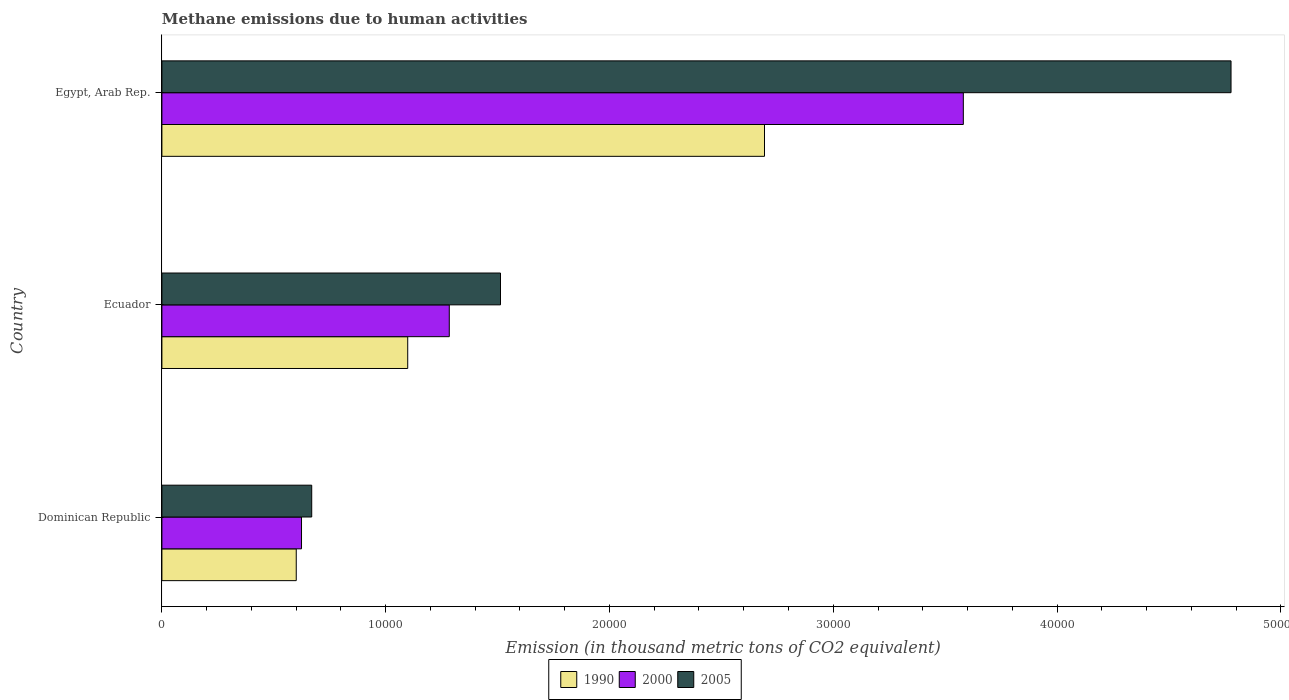How many different coloured bars are there?
Make the answer very short. 3. Are the number of bars per tick equal to the number of legend labels?
Ensure brevity in your answer.  Yes. What is the label of the 1st group of bars from the top?
Ensure brevity in your answer.  Egypt, Arab Rep. In how many cases, is the number of bars for a given country not equal to the number of legend labels?
Provide a short and direct response. 0. What is the amount of methane emitted in 1990 in Egypt, Arab Rep.?
Ensure brevity in your answer.  2.69e+04. Across all countries, what is the maximum amount of methane emitted in 2005?
Ensure brevity in your answer.  4.78e+04. Across all countries, what is the minimum amount of methane emitted in 1990?
Keep it short and to the point. 6003.8. In which country was the amount of methane emitted in 2005 maximum?
Your answer should be compact. Egypt, Arab Rep. In which country was the amount of methane emitted in 2005 minimum?
Provide a short and direct response. Dominican Republic. What is the total amount of methane emitted in 2000 in the graph?
Your response must be concise. 5.49e+04. What is the difference between the amount of methane emitted in 1990 in Ecuador and that in Egypt, Arab Rep.?
Offer a very short reply. -1.59e+04. What is the difference between the amount of methane emitted in 1990 in Dominican Republic and the amount of methane emitted in 2005 in Ecuador?
Offer a terse response. -9126.7. What is the average amount of methane emitted in 2000 per country?
Make the answer very short. 1.83e+04. What is the difference between the amount of methane emitted in 1990 and amount of methane emitted in 2000 in Ecuador?
Provide a short and direct response. -1857.4. In how many countries, is the amount of methane emitted in 2000 greater than 6000 thousand metric tons?
Keep it short and to the point. 3. What is the ratio of the amount of methane emitted in 1990 in Ecuador to that in Egypt, Arab Rep.?
Offer a very short reply. 0.41. What is the difference between the highest and the second highest amount of methane emitted in 2000?
Your answer should be very brief. 2.30e+04. What is the difference between the highest and the lowest amount of methane emitted in 2000?
Provide a short and direct response. 2.96e+04. In how many countries, is the amount of methane emitted in 2005 greater than the average amount of methane emitted in 2005 taken over all countries?
Offer a very short reply. 1. What does the 1st bar from the bottom in Dominican Republic represents?
Offer a terse response. 1990. Is it the case that in every country, the sum of the amount of methane emitted in 1990 and amount of methane emitted in 2005 is greater than the amount of methane emitted in 2000?
Your response must be concise. Yes. How many countries are there in the graph?
Your answer should be very brief. 3. What is the difference between two consecutive major ticks on the X-axis?
Offer a terse response. 10000. Are the values on the major ticks of X-axis written in scientific E-notation?
Make the answer very short. No. What is the title of the graph?
Offer a very short reply. Methane emissions due to human activities. What is the label or title of the X-axis?
Provide a short and direct response. Emission (in thousand metric tons of CO2 equivalent). What is the label or title of the Y-axis?
Give a very brief answer. Country. What is the Emission (in thousand metric tons of CO2 equivalent) of 1990 in Dominican Republic?
Your answer should be very brief. 6003.8. What is the Emission (in thousand metric tons of CO2 equivalent) of 2000 in Dominican Republic?
Offer a terse response. 6238.7. What is the Emission (in thousand metric tons of CO2 equivalent) of 2005 in Dominican Republic?
Keep it short and to the point. 6694.7. What is the Emission (in thousand metric tons of CO2 equivalent) in 1990 in Ecuador?
Your answer should be very brief. 1.10e+04. What is the Emission (in thousand metric tons of CO2 equivalent) of 2000 in Ecuador?
Offer a very short reply. 1.28e+04. What is the Emission (in thousand metric tons of CO2 equivalent) of 2005 in Ecuador?
Make the answer very short. 1.51e+04. What is the Emission (in thousand metric tons of CO2 equivalent) of 1990 in Egypt, Arab Rep.?
Provide a short and direct response. 2.69e+04. What is the Emission (in thousand metric tons of CO2 equivalent) in 2000 in Egypt, Arab Rep.?
Provide a short and direct response. 3.58e+04. What is the Emission (in thousand metric tons of CO2 equivalent) in 2005 in Egypt, Arab Rep.?
Ensure brevity in your answer.  4.78e+04. Across all countries, what is the maximum Emission (in thousand metric tons of CO2 equivalent) in 1990?
Your response must be concise. 2.69e+04. Across all countries, what is the maximum Emission (in thousand metric tons of CO2 equivalent) of 2000?
Provide a short and direct response. 3.58e+04. Across all countries, what is the maximum Emission (in thousand metric tons of CO2 equivalent) in 2005?
Ensure brevity in your answer.  4.78e+04. Across all countries, what is the minimum Emission (in thousand metric tons of CO2 equivalent) in 1990?
Offer a very short reply. 6003.8. Across all countries, what is the minimum Emission (in thousand metric tons of CO2 equivalent) of 2000?
Give a very brief answer. 6238.7. Across all countries, what is the minimum Emission (in thousand metric tons of CO2 equivalent) of 2005?
Make the answer very short. 6694.7. What is the total Emission (in thousand metric tons of CO2 equivalent) of 1990 in the graph?
Keep it short and to the point. 4.39e+04. What is the total Emission (in thousand metric tons of CO2 equivalent) of 2000 in the graph?
Provide a succinct answer. 5.49e+04. What is the total Emission (in thousand metric tons of CO2 equivalent) in 2005 in the graph?
Keep it short and to the point. 6.96e+04. What is the difference between the Emission (in thousand metric tons of CO2 equivalent) in 1990 in Dominican Republic and that in Ecuador?
Make the answer very short. -4980.8. What is the difference between the Emission (in thousand metric tons of CO2 equivalent) of 2000 in Dominican Republic and that in Ecuador?
Your answer should be very brief. -6603.3. What is the difference between the Emission (in thousand metric tons of CO2 equivalent) of 2005 in Dominican Republic and that in Ecuador?
Your response must be concise. -8435.8. What is the difference between the Emission (in thousand metric tons of CO2 equivalent) of 1990 in Dominican Republic and that in Egypt, Arab Rep.?
Offer a terse response. -2.09e+04. What is the difference between the Emission (in thousand metric tons of CO2 equivalent) of 2000 in Dominican Republic and that in Egypt, Arab Rep.?
Give a very brief answer. -2.96e+04. What is the difference between the Emission (in thousand metric tons of CO2 equivalent) of 2005 in Dominican Republic and that in Egypt, Arab Rep.?
Ensure brevity in your answer.  -4.11e+04. What is the difference between the Emission (in thousand metric tons of CO2 equivalent) of 1990 in Ecuador and that in Egypt, Arab Rep.?
Give a very brief answer. -1.59e+04. What is the difference between the Emission (in thousand metric tons of CO2 equivalent) in 2000 in Ecuador and that in Egypt, Arab Rep.?
Your answer should be very brief. -2.30e+04. What is the difference between the Emission (in thousand metric tons of CO2 equivalent) of 2005 in Ecuador and that in Egypt, Arab Rep.?
Make the answer very short. -3.26e+04. What is the difference between the Emission (in thousand metric tons of CO2 equivalent) in 1990 in Dominican Republic and the Emission (in thousand metric tons of CO2 equivalent) in 2000 in Ecuador?
Your response must be concise. -6838.2. What is the difference between the Emission (in thousand metric tons of CO2 equivalent) of 1990 in Dominican Republic and the Emission (in thousand metric tons of CO2 equivalent) of 2005 in Ecuador?
Your answer should be compact. -9126.7. What is the difference between the Emission (in thousand metric tons of CO2 equivalent) of 2000 in Dominican Republic and the Emission (in thousand metric tons of CO2 equivalent) of 2005 in Ecuador?
Your answer should be very brief. -8891.8. What is the difference between the Emission (in thousand metric tons of CO2 equivalent) in 1990 in Dominican Republic and the Emission (in thousand metric tons of CO2 equivalent) in 2000 in Egypt, Arab Rep.?
Provide a succinct answer. -2.98e+04. What is the difference between the Emission (in thousand metric tons of CO2 equivalent) of 1990 in Dominican Republic and the Emission (in thousand metric tons of CO2 equivalent) of 2005 in Egypt, Arab Rep.?
Give a very brief answer. -4.18e+04. What is the difference between the Emission (in thousand metric tons of CO2 equivalent) of 2000 in Dominican Republic and the Emission (in thousand metric tons of CO2 equivalent) of 2005 in Egypt, Arab Rep.?
Keep it short and to the point. -4.15e+04. What is the difference between the Emission (in thousand metric tons of CO2 equivalent) in 1990 in Ecuador and the Emission (in thousand metric tons of CO2 equivalent) in 2000 in Egypt, Arab Rep.?
Your answer should be compact. -2.48e+04. What is the difference between the Emission (in thousand metric tons of CO2 equivalent) of 1990 in Ecuador and the Emission (in thousand metric tons of CO2 equivalent) of 2005 in Egypt, Arab Rep.?
Your answer should be compact. -3.68e+04. What is the difference between the Emission (in thousand metric tons of CO2 equivalent) in 2000 in Ecuador and the Emission (in thousand metric tons of CO2 equivalent) in 2005 in Egypt, Arab Rep.?
Keep it short and to the point. -3.49e+04. What is the average Emission (in thousand metric tons of CO2 equivalent) of 1990 per country?
Make the answer very short. 1.46e+04. What is the average Emission (in thousand metric tons of CO2 equivalent) in 2000 per country?
Give a very brief answer. 1.83e+04. What is the average Emission (in thousand metric tons of CO2 equivalent) of 2005 per country?
Your answer should be very brief. 2.32e+04. What is the difference between the Emission (in thousand metric tons of CO2 equivalent) of 1990 and Emission (in thousand metric tons of CO2 equivalent) of 2000 in Dominican Republic?
Offer a very short reply. -234.9. What is the difference between the Emission (in thousand metric tons of CO2 equivalent) in 1990 and Emission (in thousand metric tons of CO2 equivalent) in 2005 in Dominican Republic?
Your answer should be very brief. -690.9. What is the difference between the Emission (in thousand metric tons of CO2 equivalent) of 2000 and Emission (in thousand metric tons of CO2 equivalent) of 2005 in Dominican Republic?
Provide a short and direct response. -456. What is the difference between the Emission (in thousand metric tons of CO2 equivalent) in 1990 and Emission (in thousand metric tons of CO2 equivalent) in 2000 in Ecuador?
Keep it short and to the point. -1857.4. What is the difference between the Emission (in thousand metric tons of CO2 equivalent) of 1990 and Emission (in thousand metric tons of CO2 equivalent) of 2005 in Ecuador?
Your answer should be very brief. -4145.9. What is the difference between the Emission (in thousand metric tons of CO2 equivalent) in 2000 and Emission (in thousand metric tons of CO2 equivalent) in 2005 in Ecuador?
Ensure brevity in your answer.  -2288.5. What is the difference between the Emission (in thousand metric tons of CO2 equivalent) in 1990 and Emission (in thousand metric tons of CO2 equivalent) in 2000 in Egypt, Arab Rep.?
Provide a short and direct response. -8884.8. What is the difference between the Emission (in thousand metric tons of CO2 equivalent) in 1990 and Emission (in thousand metric tons of CO2 equivalent) in 2005 in Egypt, Arab Rep.?
Make the answer very short. -2.08e+04. What is the difference between the Emission (in thousand metric tons of CO2 equivalent) of 2000 and Emission (in thousand metric tons of CO2 equivalent) of 2005 in Egypt, Arab Rep.?
Offer a terse response. -1.20e+04. What is the ratio of the Emission (in thousand metric tons of CO2 equivalent) of 1990 in Dominican Republic to that in Ecuador?
Ensure brevity in your answer.  0.55. What is the ratio of the Emission (in thousand metric tons of CO2 equivalent) in 2000 in Dominican Republic to that in Ecuador?
Offer a terse response. 0.49. What is the ratio of the Emission (in thousand metric tons of CO2 equivalent) in 2005 in Dominican Republic to that in Ecuador?
Your response must be concise. 0.44. What is the ratio of the Emission (in thousand metric tons of CO2 equivalent) in 1990 in Dominican Republic to that in Egypt, Arab Rep.?
Give a very brief answer. 0.22. What is the ratio of the Emission (in thousand metric tons of CO2 equivalent) of 2000 in Dominican Republic to that in Egypt, Arab Rep.?
Give a very brief answer. 0.17. What is the ratio of the Emission (in thousand metric tons of CO2 equivalent) in 2005 in Dominican Republic to that in Egypt, Arab Rep.?
Your answer should be very brief. 0.14. What is the ratio of the Emission (in thousand metric tons of CO2 equivalent) in 1990 in Ecuador to that in Egypt, Arab Rep.?
Make the answer very short. 0.41. What is the ratio of the Emission (in thousand metric tons of CO2 equivalent) of 2000 in Ecuador to that in Egypt, Arab Rep.?
Keep it short and to the point. 0.36. What is the ratio of the Emission (in thousand metric tons of CO2 equivalent) of 2005 in Ecuador to that in Egypt, Arab Rep.?
Give a very brief answer. 0.32. What is the difference between the highest and the second highest Emission (in thousand metric tons of CO2 equivalent) in 1990?
Offer a very short reply. 1.59e+04. What is the difference between the highest and the second highest Emission (in thousand metric tons of CO2 equivalent) of 2000?
Your answer should be compact. 2.30e+04. What is the difference between the highest and the second highest Emission (in thousand metric tons of CO2 equivalent) in 2005?
Keep it short and to the point. 3.26e+04. What is the difference between the highest and the lowest Emission (in thousand metric tons of CO2 equivalent) in 1990?
Your answer should be compact. 2.09e+04. What is the difference between the highest and the lowest Emission (in thousand metric tons of CO2 equivalent) of 2000?
Ensure brevity in your answer.  2.96e+04. What is the difference between the highest and the lowest Emission (in thousand metric tons of CO2 equivalent) of 2005?
Your answer should be very brief. 4.11e+04. 